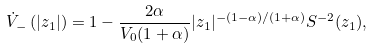Convert formula to latex. <formula><loc_0><loc_0><loc_500><loc_500>\dot { V } _ { - } \left ( | z _ { 1 } | \right ) = 1 - \frac { 2 \alpha } { V _ { 0 } ( 1 + \alpha ) } | z _ { 1 } | ^ { - ( 1 - \alpha ) / ( 1 + \alpha ) } S ^ { - 2 } ( z _ { 1 } ) ,</formula> 